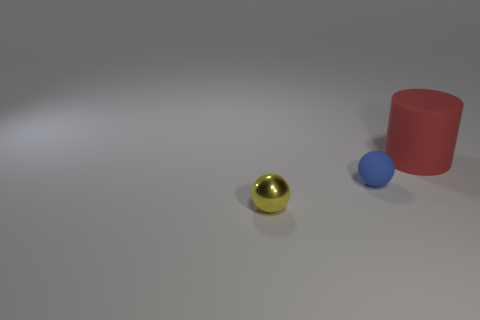Add 1 tiny matte spheres. How many objects exist? 4 Subtract all cylinders. How many objects are left? 2 Subtract all small yellow shiny objects. Subtract all tiny objects. How many objects are left? 0 Add 1 tiny yellow metal objects. How many tiny yellow metal objects are left? 2 Add 2 small objects. How many small objects exist? 4 Subtract 0 blue cylinders. How many objects are left? 3 